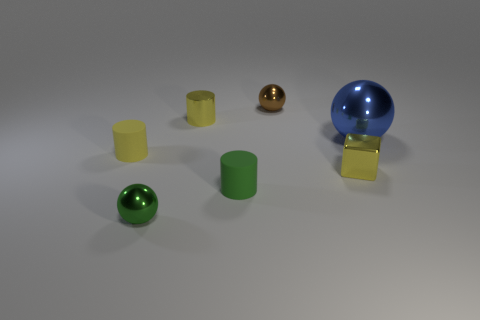Add 1 big purple balls. How many objects exist? 8 Subtract all cylinders. How many objects are left? 4 Add 1 shiny objects. How many shiny objects are left? 6 Add 4 green spheres. How many green spheres exist? 5 Subtract 0 gray blocks. How many objects are left? 7 Subtract all balls. Subtract all shiny spheres. How many objects are left? 1 